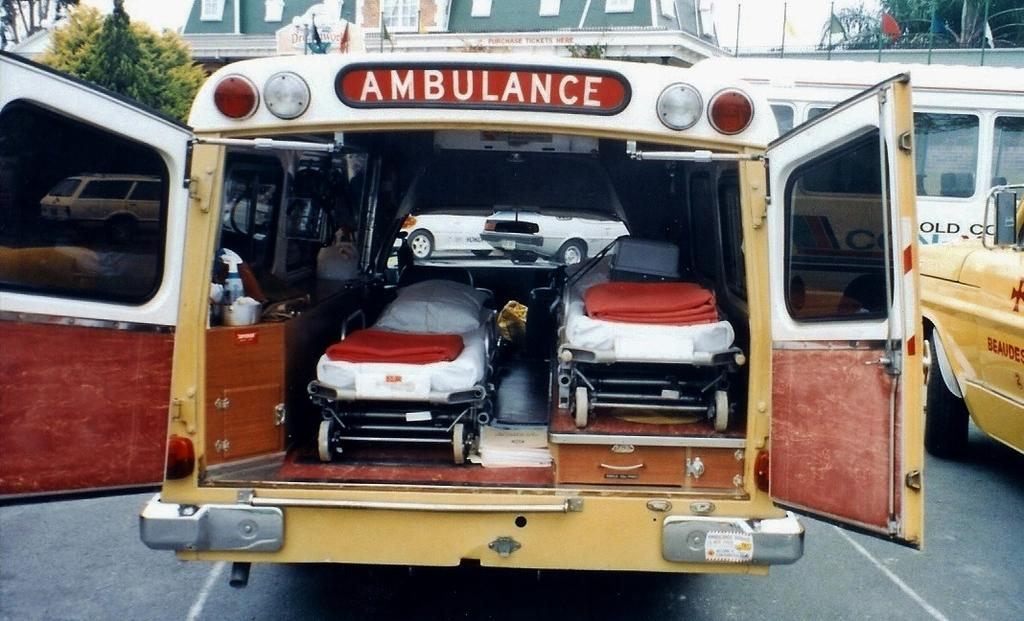What is the main subject of the image? The main subject of the image is an ambulance. What can be found inside the ambulance? There are beds inside the ambulance. What is visible in the background of the image? In the background of the image, there are vehicles on a road, buildings, and a tree. What type of jeans is the dad wearing in the image? There is no dad or jeans present in the image; it features an ambulance with beds inside and a background with vehicles, buildings, and a tree. 